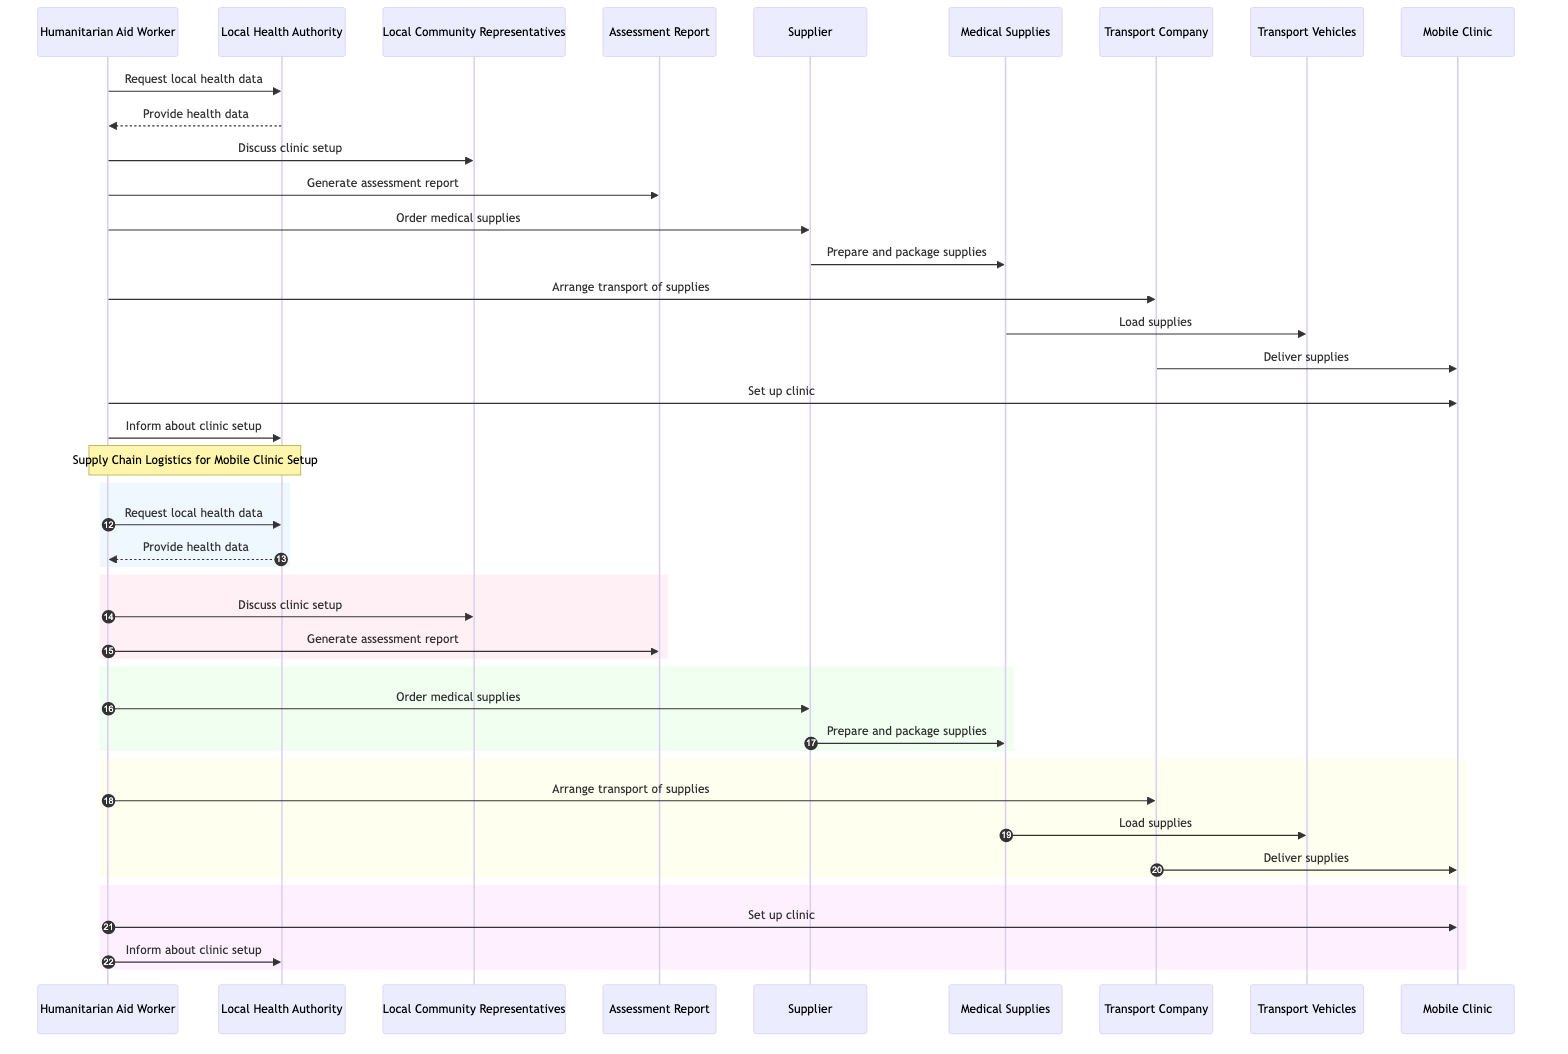What's the total number of actors in the diagram? The diagram lists five actors: Humanitarian Aid Worker, Local Health Authority, Supplier, Transport Company, and Local Community Representatives.
Answer: 5 What action does the Humanitarian Aid Worker take after discussing clinic setup? After discussing clinic setup with Local Community Representatives, the Humanitarian Aid Worker generates the assessment report.
Answer: Generate assessment report How many messages are exchanged between the Humanitarian Aid Worker and the Local Health Authority? There are two messages exchanged: the Humanitarian Aid Worker requests local health data, and the Local Health Authority provides the health data.
Answer: 2 What is the role of the Supplier in this process? The Supplier's role is to prepare and package the medical supplies ordered by the Humanitarian Aid Worker.
Answer: Prepare and package supplies Which actor orders the medical supplies? The Humanitarian Aid Worker is responsible for ordering the medical supplies from the Supplier.
Answer: Humanitarian Aid Worker What happens to the medical supplies after they are prepared? After being prepared and packaged, the medical supplies are loaded onto the transport vehicles for delivery.
Answer: Load supplies Which actor is responsible for delivering the supplies to the Mobile Clinic? The Transport Company is responsible for delivering the supplies to the Mobile Clinic.
Answer: Transport Company What is the final step taken by the Humanitarian Aid Worker in the sequence? The final step taken by the Humanitarian Aid Worker is to inform the Local Health Authority about the setup of the clinic.
Answer: Inform about clinic setup How many distinct steps are there between ordering and setting up the clinic? There are four distinct steps: order medical supplies, prepare and package supplies, arrange transport, and deliver supplies.
Answer: 4 What is the purpose of the Assessment Report in the sequence? The purpose of the Assessment Report is to analyze the local health situation to inform clinic setup decisions.
Answer: Inform clinic setup decisions 